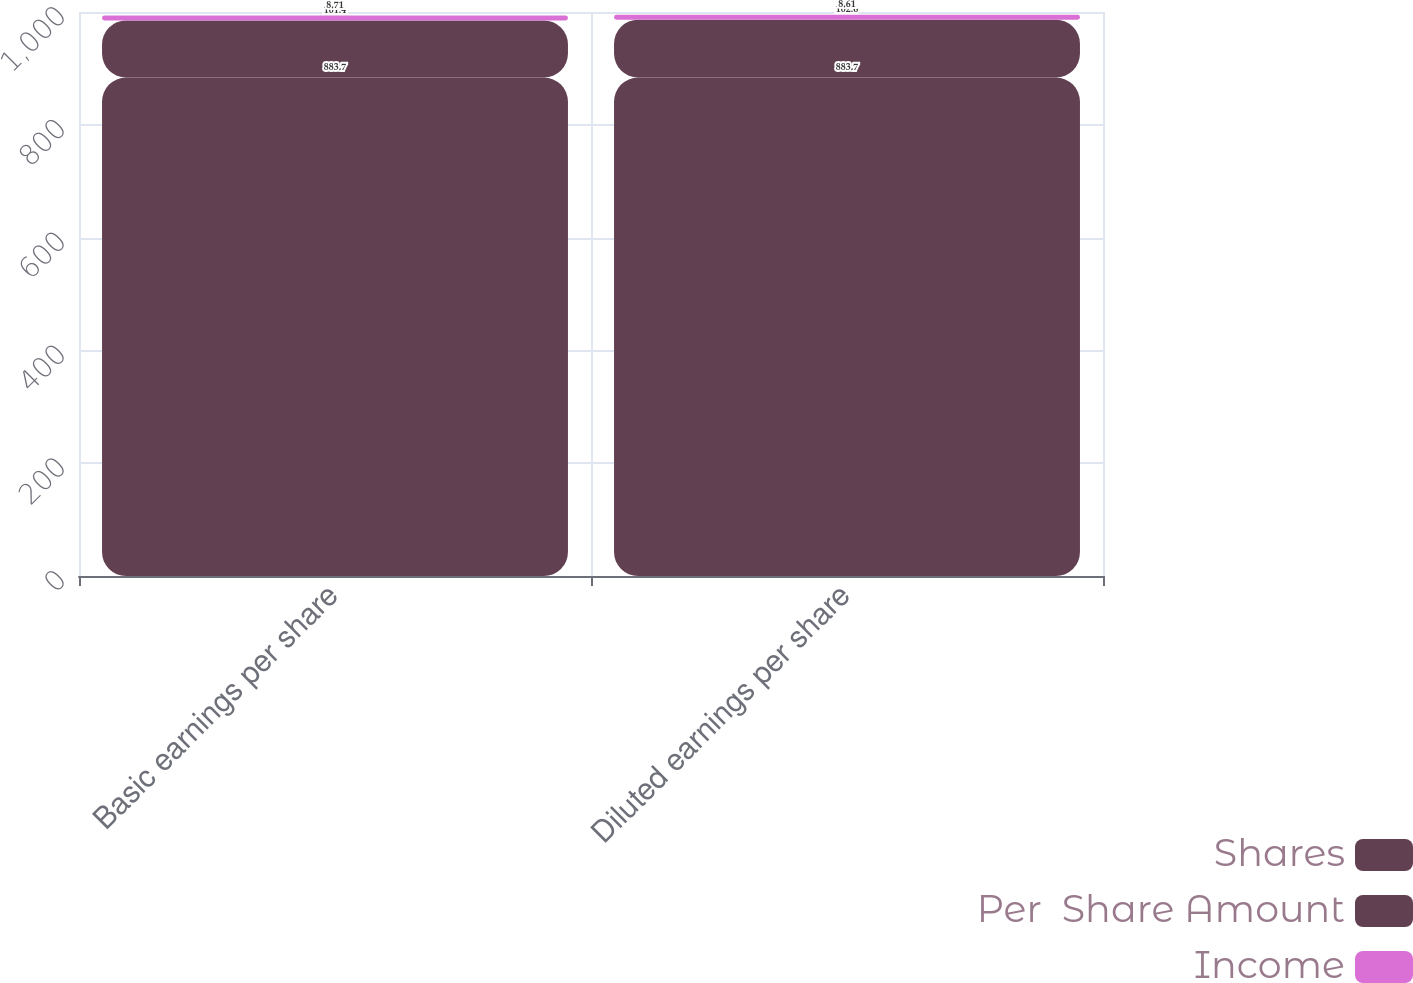Convert chart. <chart><loc_0><loc_0><loc_500><loc_500><stacked_bar_chart><ecel><fcel>Basic earnings per share<fcel>Diluted earnings per share<nl><fcel>Shares<fcel>883.7<fcel>883.7<nl><fcel>Per  Share Amount<fcel>101.4<fcel>102.6<nl><fcel>Income<fcel>8.71<fcel>8.61<nl></chart> 